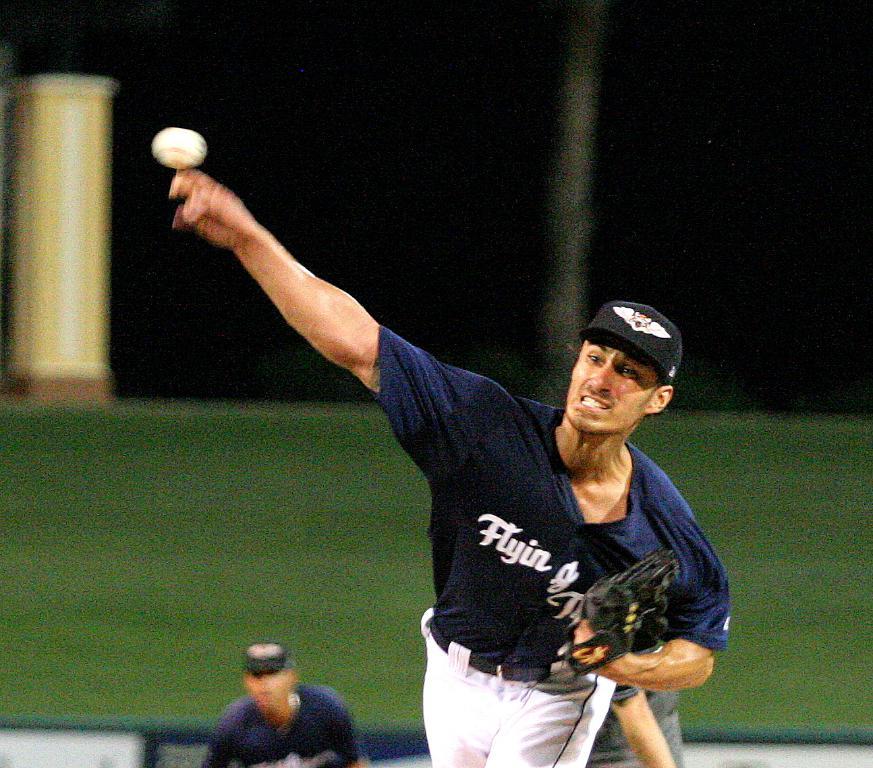What tam does the pitcher play on?
Give a very brief answer. Flyin. 